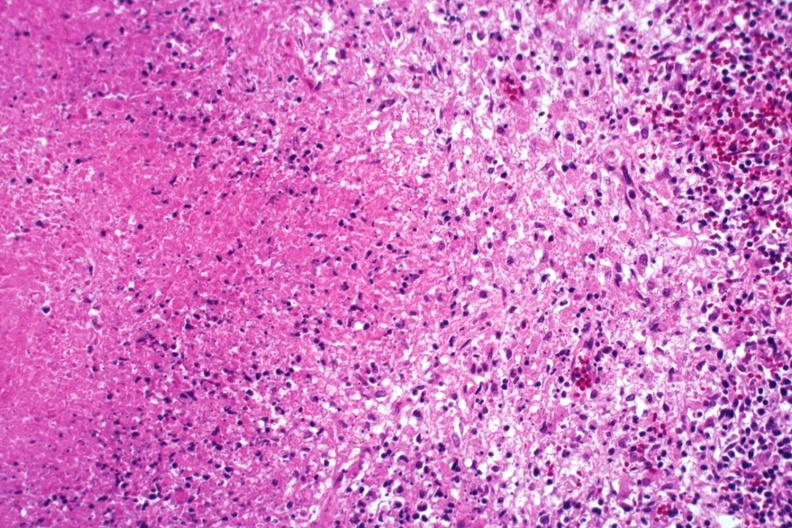s lymph node present?
Answer the question using a single word or phrase. Yes 